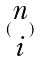<formula> <loc_0><loc_0><loc_500><loc_500>( \begin{matrix} n \\ i \end{matrix} )</formula> 